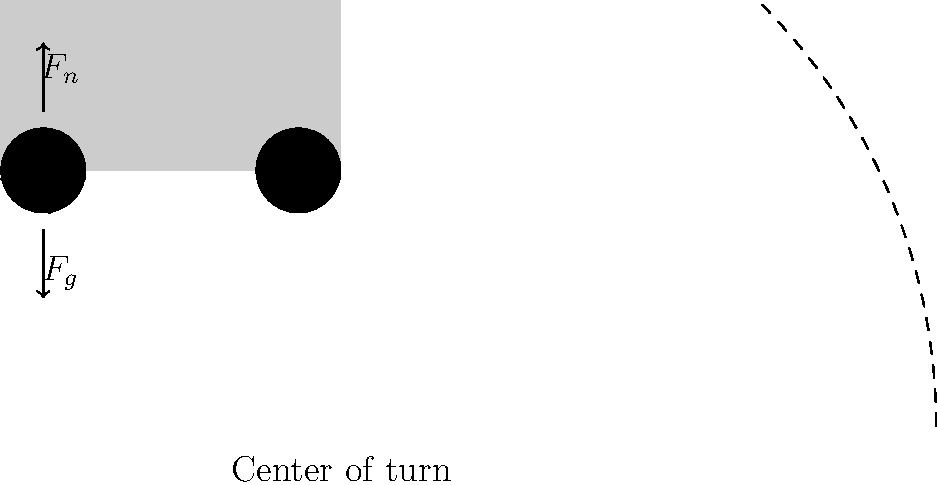As a delivery driver, you're making a right turn in your vehicle. Which force acting on the front left tire prevents the vehicle from sliding outward during the turn, and how does it relate to the other forces shown in the diagram? Let's break this down step-by-step:

1. The diagram shows three main forces acting on the tire:
   - $F_n$: Normal force (upward)
   - $F_g$: Gravitational force (downward)
   - $F_f$: Frictional force (horizontal)

2. When a vehicle turns, it experiences a centripetal force that pulls it towards the center of the turn. Without this force, the vehicle would continue in a straight line due to inertia.

3. The force that provides this centripetal acceleration is the frictional force $F_f$ between the tire and the road.

4. This frictional force is dependent on the normal force $F_n$. The relationship is given by:

   $$F_f \leq \mu F_n$$

   where $\mu$ is the coefficient of friction between the tire and the road.

5. The normal force $F_n$ is essentially balancing the gravitational force $F_g$, keeping the vehicle on the road.

6. During a turn, weight transfer occurs, increasing the normal force on the outer tires (in this case, the front left tire for a right turn). This increased normal force allows for a greater frictional force, which is crucial for maintaining the turn.

7. If the frictional force is insufficient (due to factors like high speed, slippery road conditions, or a turn that's too sharp), the vehicle will slide outward, potentially causing a skid or rollover.

Therefore, the frictional force $F_f$ is the key force preventing the vehicle from sliding outward during the turn, and its magnitude is directly related to the normal force $F_n$ acting on the tire.
Answer: Frictional force $F_f$, proportional to normal force $F_n$ 